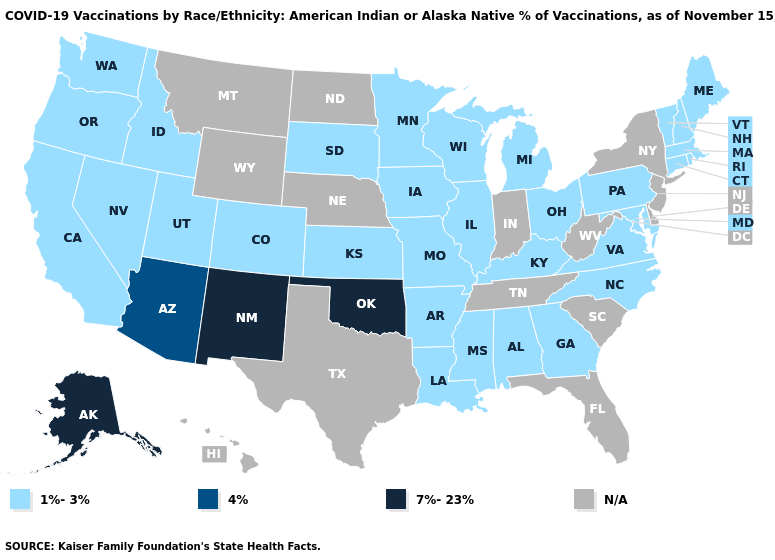Name the states that have a value in the range N/A?
Quick response, please. Delaware, Florida, Hawaii, Indiana, Montana, Nebraska, New Jersey, New York, North Dakota, South Carolina, Tennessee, Texas, West Virginia, Wyoming. What is the value of Idaho?
Write a very short answer. 1%-3%. What is the lowest value in states that border Connecticut?
Write a very short answer. 1%-3%. What is the highest value in the USA?
Be succinct. 7%-23%. Which states have the lowest value in the USA?
Quick response, please. Alabama, Arkansas, California, Colorado, Connecticut, Georgia, Idaho, Illinois, Iowa, Kansas, Kentucky, Louisiana, Maine, Maryland, Massachusetts, Michigan, Minnesota, Mississippi, Missouri, Nevada, New Hampshire, North Carolina, Ohio, Oregon, Pennsylvania, Rhode Island, South Dakota, Utah, Vermont, Virginia, Washington, Wisconsin. Name the states that have a value in the range 1%-3%?
Write a very short answer. Alabama, Arkansas, California, Colorado, Connecticut, Georgia, Idaho, Illinois, Iowa, Kansas, Kentucky, Louisiana, Maine, Maryland, Massachusetts, Michigan, Minnesota, Mississippi, Missouri, Nevada, New Hampshire, North Carolina, Ohio, Oregon, Pennsylvania, Rhode Island, South Dakota, Utah, Vermont, Virginia, Washington, Wisconsin. How many symbols are there in the legend?
Write a very short answer. 4. What is the lowest value in the Northeast?
Concise answer only. 1%-3%. Which states hav the highest value in the West?
Keep it brief. Alaska, New Mexico. Name the states that have a value in the range 7%-23%?
Short answer required. Alaska, New Mexico, Oklahoma. What is the value of Oklahoma?
Be succinct. 7%-23%. Among the states that border Minnesota , which have the highest value?
Answer briefly. Iowa, South Dakota, Wisconsin. Does Alaska have the lowest value in the West?
Keep it brief. No. 